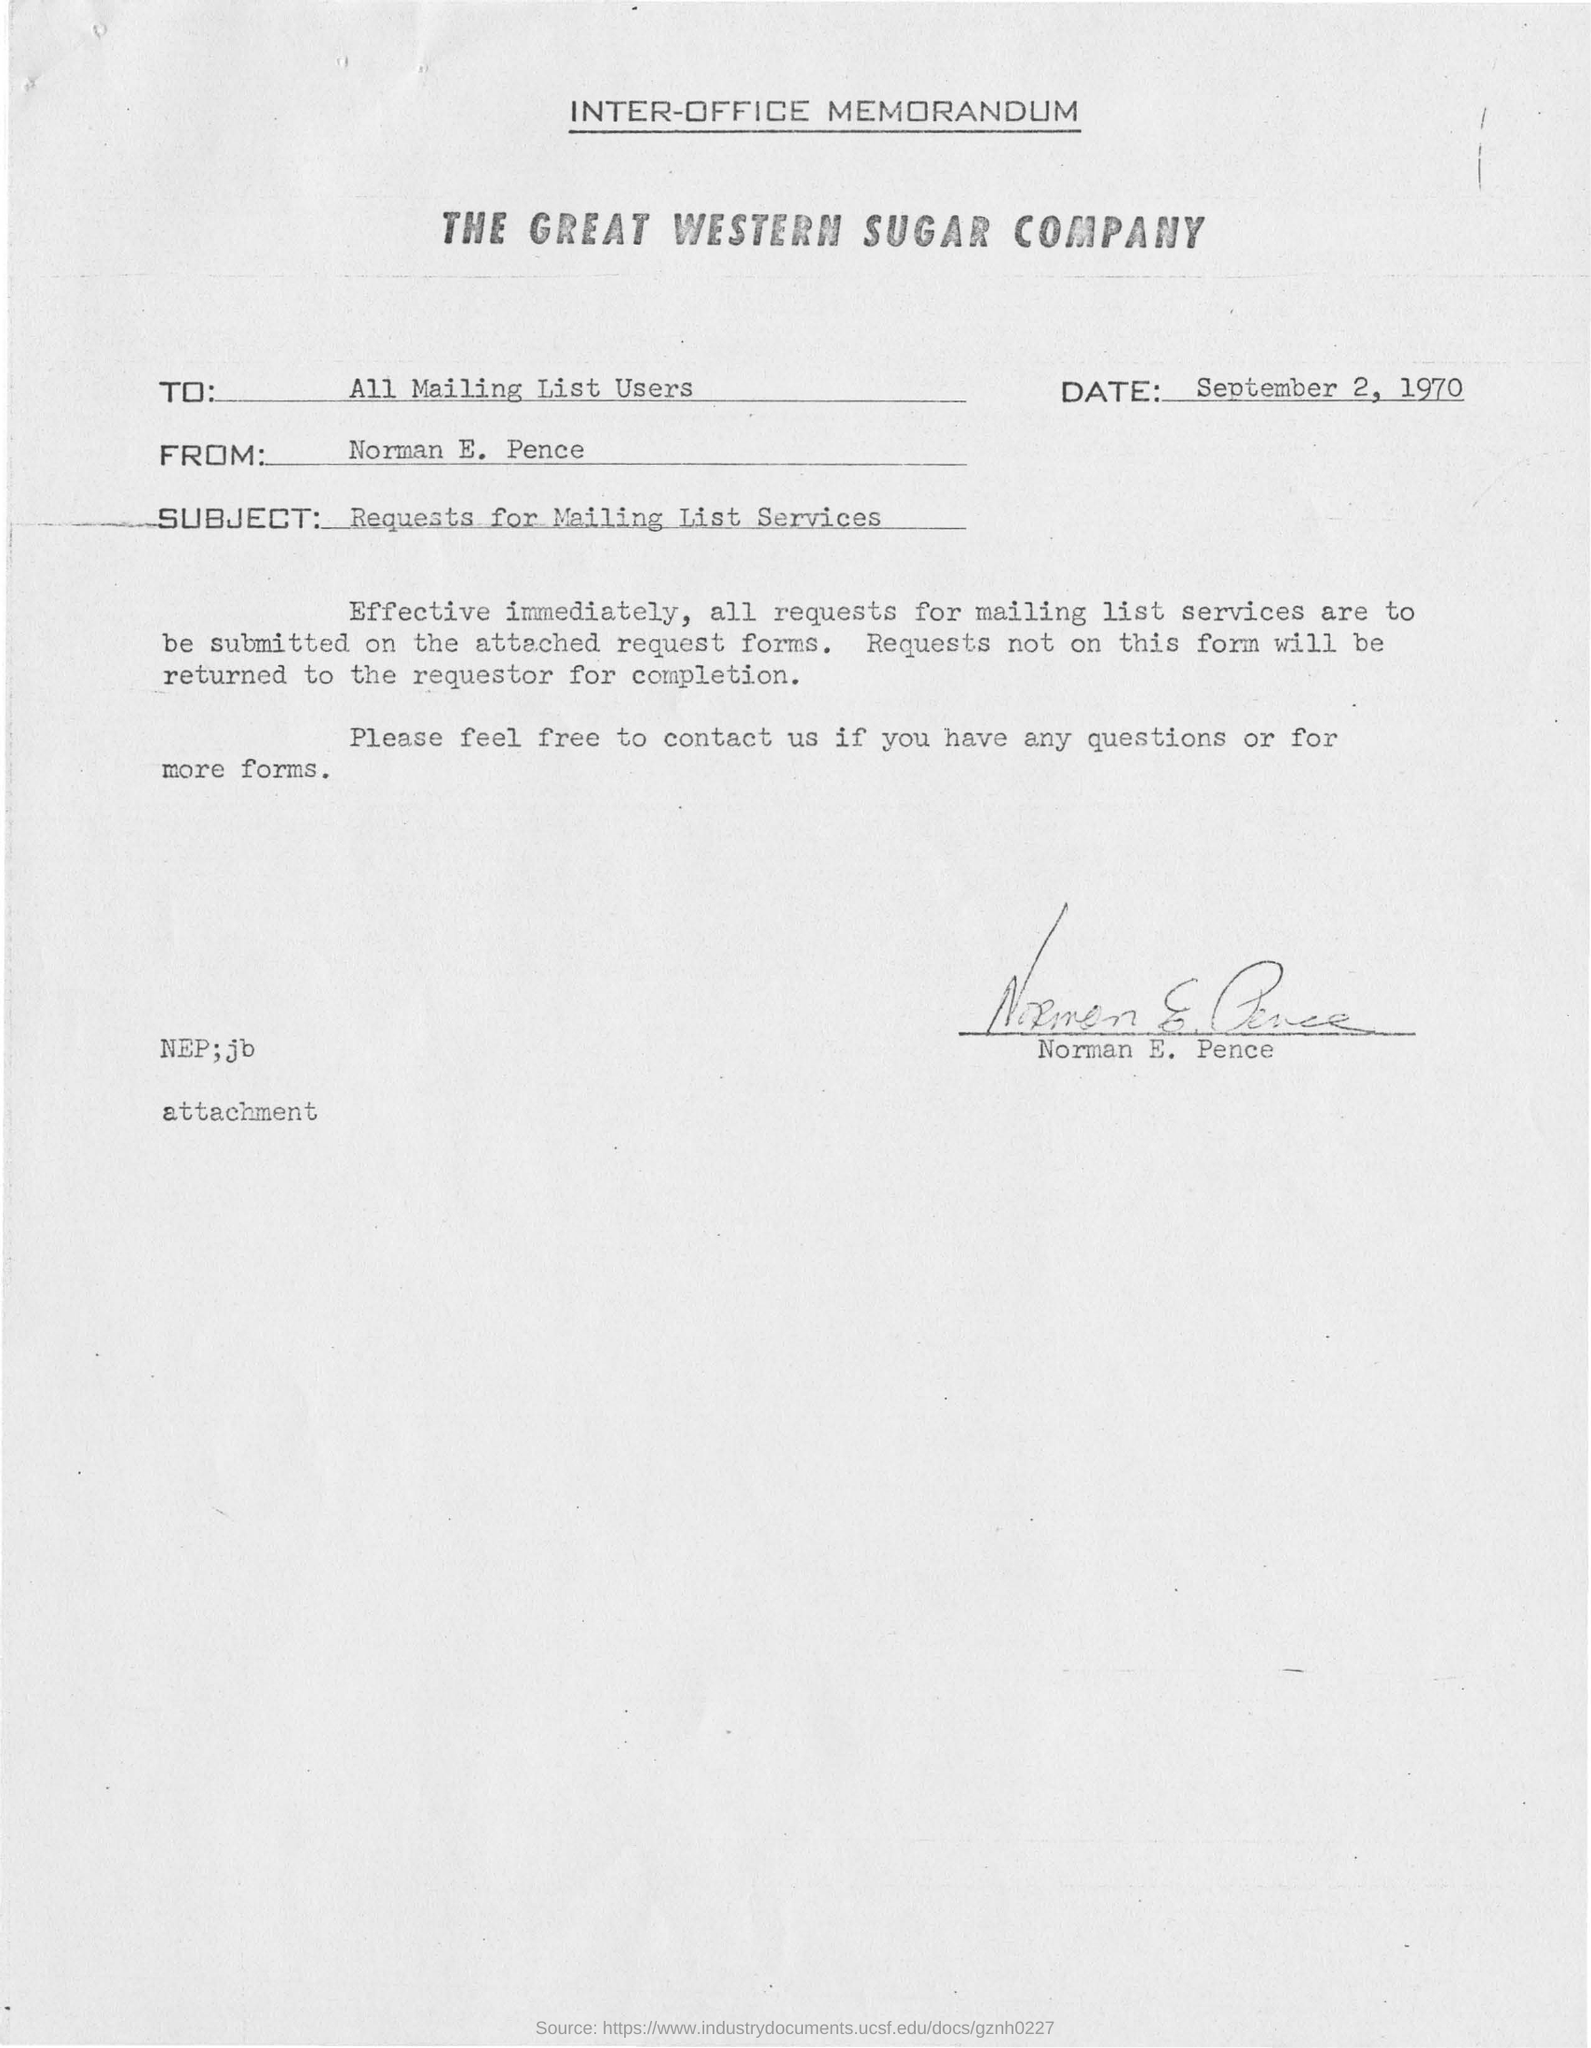To whom this was written
Provide a succinct answer. All Mailing List Users. What is the subject mentioned ?
Provide a succinct answer. Requests for mailing list services. Who's signature was there in this memorandum ?
Your answer should be compact. Norman E. Pence. What is the date mentioned in the memorandum ?
Make the answer very short. September 2, 1970. What is the name of the company mentioned in the inter office memorandum ?
Offer a very short reply. The great western sugar company. 